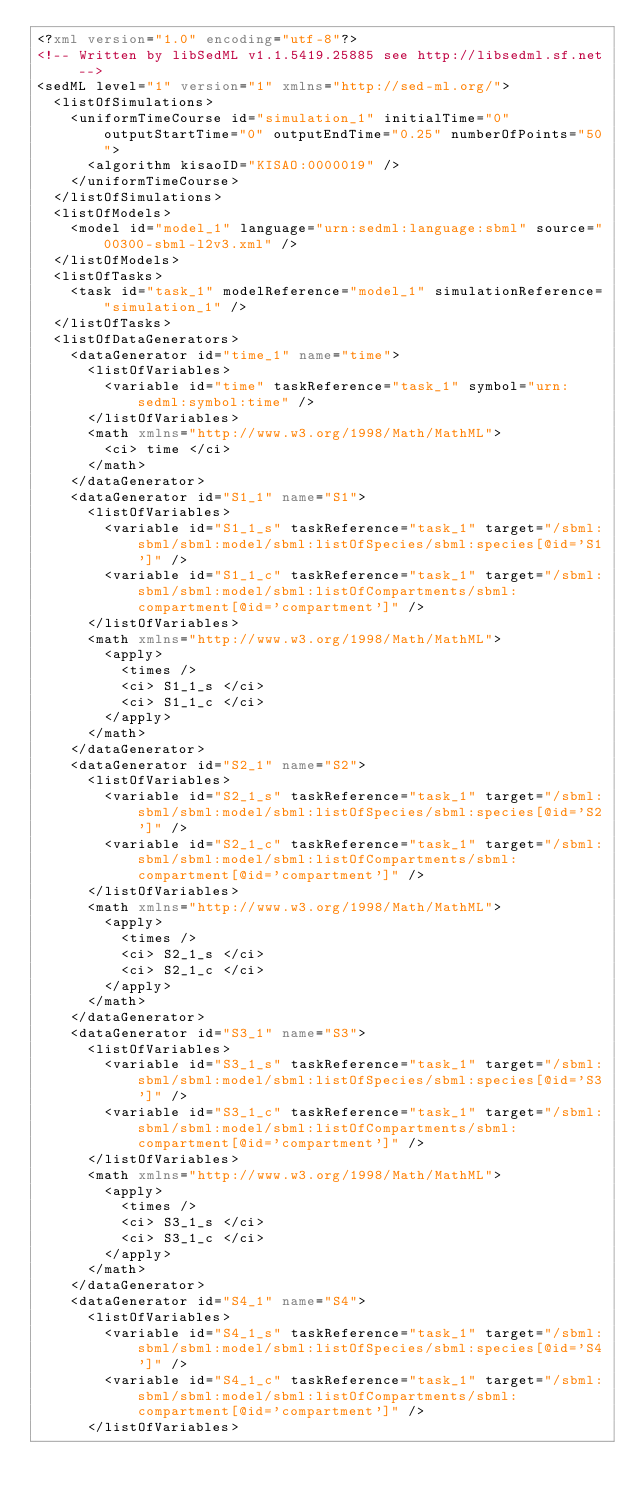<code> <loc_0><loc_0><loc_500><loc_500><_XML_><?xml version="1.0" encoding="utf-8"?>
<!-- Written by libSedML v1.1.5419.25885 see http://libsedml.sf.net -->
<sedML level="1" version="1" xmlns="http://sed-ml.org/">
  <listOfSimulations>
    <uniformTimeCourse id="simulation_1" initialTime="0" outputStartTime="0" outputEndTime="0.25" numberOfPoints="50">
      <algorithm kisaoID="KISAO:0000019" />
    </uniformTimeCourse>
  </listOfSimulations>
  <listOfModels>
    <model id="model_1" language="urn:sedml:language:sbml" source="00300-sbml-l2v3.xml" />
  </listOfModels>
  <listOfTasks>
    <task id="task_1" modelReference="model_1" simulationReference="simulation_1" />
  </listOfTasks>
  <listOfDataGenerators>
    <dataGenerator id="time_1" name="time">
      <listOfVariables>
        <variable id="time" taskReference="task_1" symbol="urn:sedml:symbol:time" />
      </listOfVariables>
      <math xmlns="http://www.w3.org/1998/Math/MathML">
        <ci> time </ci>
      </math>
    </dataGenerator>
    <dataGenerator id="S1_1" name="S1">
      <listOfVariables>
        <variable id="S1_1_s" taskReference="task_1" target="/sbml:sbml/sbml:model/sbml:listOfSpecies/sbml:species[@id='S1']" />
        <variable id="S1_1_c" taskReference="task_1" target="/sbml:sbml/sbml:model/sbml:listOfCompartments/sbml:compartment[@id='compartment']" />
      </listOfVariables>
      <math xmlns="http://www.w3.org/1998/Math/MathML">
        <apply>
          <times />
          <ci> S1_1_s </ci>
          <ci> S1_1_c </ci>
        </apply>
      </math>
    </dataGenerator>
    <dataGenerator id="S2_1" name="S2">
      <listOfVariables>
        <variable id="S2_1_s" taskReference="task_1" target="/sbml:sbml/sbml:model/sbml:listOfSpecies/sbml:species[@id='S2']" />
        <variable id="S2_1_c" taskReference="task_1" target="/sbml:sbml/sbml:model/sbml:listOfCompartments/sbml:compartment[@id='compartment']" />
      </listOfVariables>
      <math xmlns="http://www.w3.org/1998/Math/MathML">
        <apply>
          <times />
          <ci> S2_1_s </ci>
          <ci> S2_1_c </ci>
        </apply>
      </math>
    </dataGenerator>
    <dataGenerator id="S3_1" name="S3">
      <listOfVariables>
        <variable id="S3_1_s" taskReference="task_1" target="/sbml:sbml/sbml:model/sbml:listOfSpecies/sbml:species[@id='S3']" />
        <variable id="S3_1_c" taskReference="task_1" target="/sbml:sbml/sbml:model/sbml:listOfCompartments/sbml:compartment[@id='compartment']" />
      </listOfVariables>
      <math xmlns="http://www.w3.org/1998/Math/MathML">
        <apply>
          <times />
          <ci> S3_1_s </ci>
          <ci> S3_1_c </ci>
        </apply>
      </math>
    </dataGenerator>
    <dataGenerator id="S4_1" name="S4">
      <listOfVariables>
        <variable id="S4_1_s" taskReference="task_1" target="/sbml:sbml/sbml:model/sbml:listOfSpecies/sbml:species[@id='S4']" />
        <variable id="S4_1_c" taskReference="task_1" target="/sbml:sbml/sbml:model/sbml:listOfCompartments/sbml:compartment[@id='compartment']" />
      </listOfVariables></code> 